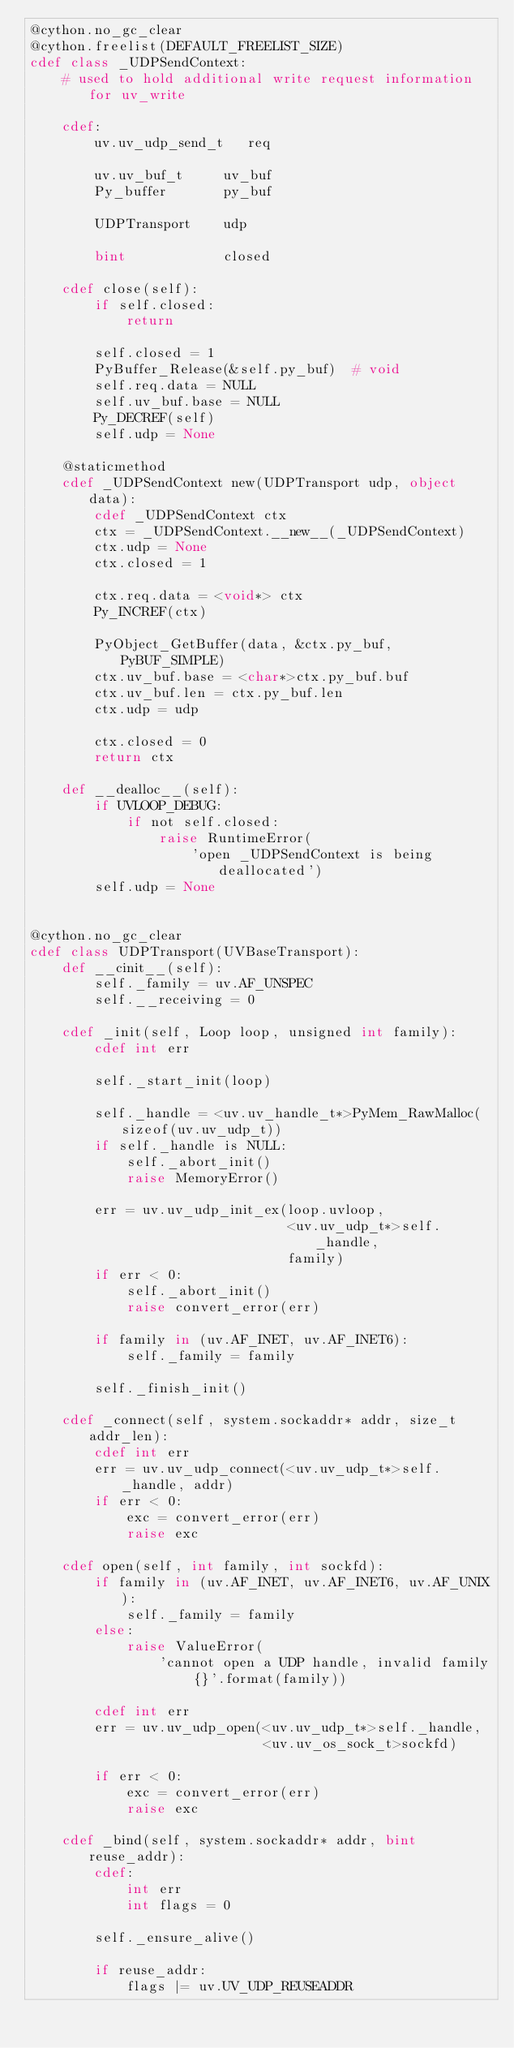Convert code to text. <code><loc_0><loc_0><loc_500><loc_500><_Cython_>@cython.no_gc_clear
@cython.freelist(DEFAULT_FREELIST_SIZE)
cdef class _UDPSendContext:
    # used to hold additional write request information for uv_write

    cdef:
        uv.uv_udp_send_t   req

        uv.uv_buf_t     uv_buf
        Py_buffer       py_buf

        UDPTransport    udp

        bint            closed

    cdef close(self):
        if self.closed:
            return

        self.closed = 1
        PyBuffer_Release(&self.py_buf)  # void
        self.req.data = NULL
        self.uv_buf.base = NULL
        Py_DECREF(self)
        self.udp = None

    @staticmethod
    cdef _UDPSendContext new(UDPTransport udp, object data):
        cdef _UDPSendContext ctx
        ctx = _UDPSendContext.__new__(_UDPSendContext)
        ctx.udp = None
        ctx.closed = 1

        ctx.req.data = <void*> ctx
        Py_INCREF(ctx)

        PyObject_GetBuffer(data, &ctx.py_buf, PyBUF_SIMPLE)
        ctx.uv_buf.base = <char*>ctx.py_buf.buf
        ctx.uv_buf.len = ctx.py_buf.len
        ctx.udp = udp

        ctx.closed = 0
        return ctx

    def __dealloc__(self):
        if UVLOOP_DEBUG:
            if not self.closed:
                raise RuntimeError(
                    'open _UDPSendContext is being deallocated')
        self.udp = None


@cython.no_gc_clear
cdef class UDPTransport(UVBaseTransport):
    def __cinit__(self):
        self._family = uv.AF_UNSPEC
        self.__receiving = 0

    cdef _init(self, Loop loop, unsigned int family):
        cdef int err

        self._start_init(loop)

        self._handle = <uv.uv_handle_t*>PyMem_RawMalloc(sizeof(uv.uv_udp_t))
        if self._handle is NULL:
            self._abort_init()
            raise MemoryError()

        err = uv.uv_udp_init_ex(loop.uvloop,
                                <uv.uv_udp_t*>self._handle,
                                family)
        if err < 0:
            self._abort_init()
            raise convert_error(err)

        if family in (uv.AF_INET, uv.AF_INET6):
            self._family = family

        self._finish_init()

    cdef _connect(self, system.sockaddr* addr, size_t addr_len):
        cdef int err
        err = uv.uv_udp_connect(<uv.uv_udp_t*>self._handle, addr)
        if err < 0:
            exc = convert_error(err)
            raise exc

    cdef open(self, int family, int sockfd):
        if family in (uv.AF_INET, uv.AF_INET6, uv.AF_UNIX):
            self._family = family
        else:
            raise ValueError(
                'cannot open a UDP handle, invalid family {}'.format(family))

        cdef int err
        err = uv.uv_udp_open(<uv.uv_udp_t*>self._handle,
                             <uv.uv_os_sock_t>sockfd)

        if err < 0:
            exc = convert_error(err)
            raise exc

    cdef _bind(self, system.sockaddr* addr, bint reuse_addr):
        cdef:
            int err
            int flags = 0

        self._ensure_alive()

        if reuse_addr:
            flags |= uv.UV_UDP_REUSEADDR
</code> 